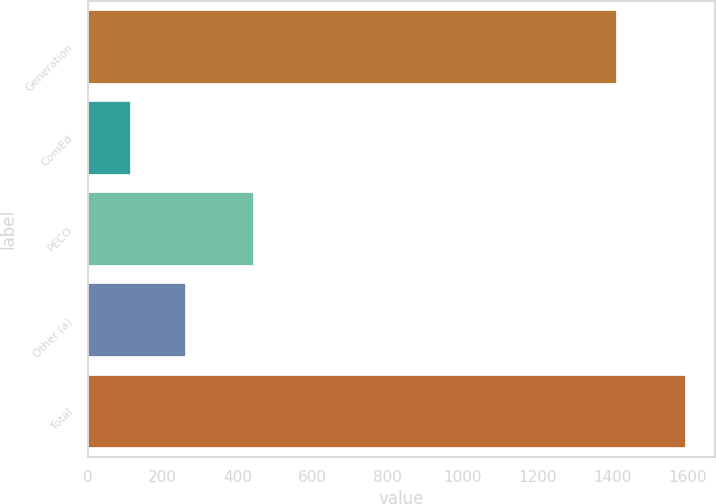<chart> <loc_0><loc_0><loc_500><loc_500><bar_chart><fcel>Generation<fcel>ComEd<fcel>PECO<fcel>Other (a)<fcel>Total<nl><fcel>1407<fcel>112<fcel>441<fcel>260<fcel>1592<nl></chart> 